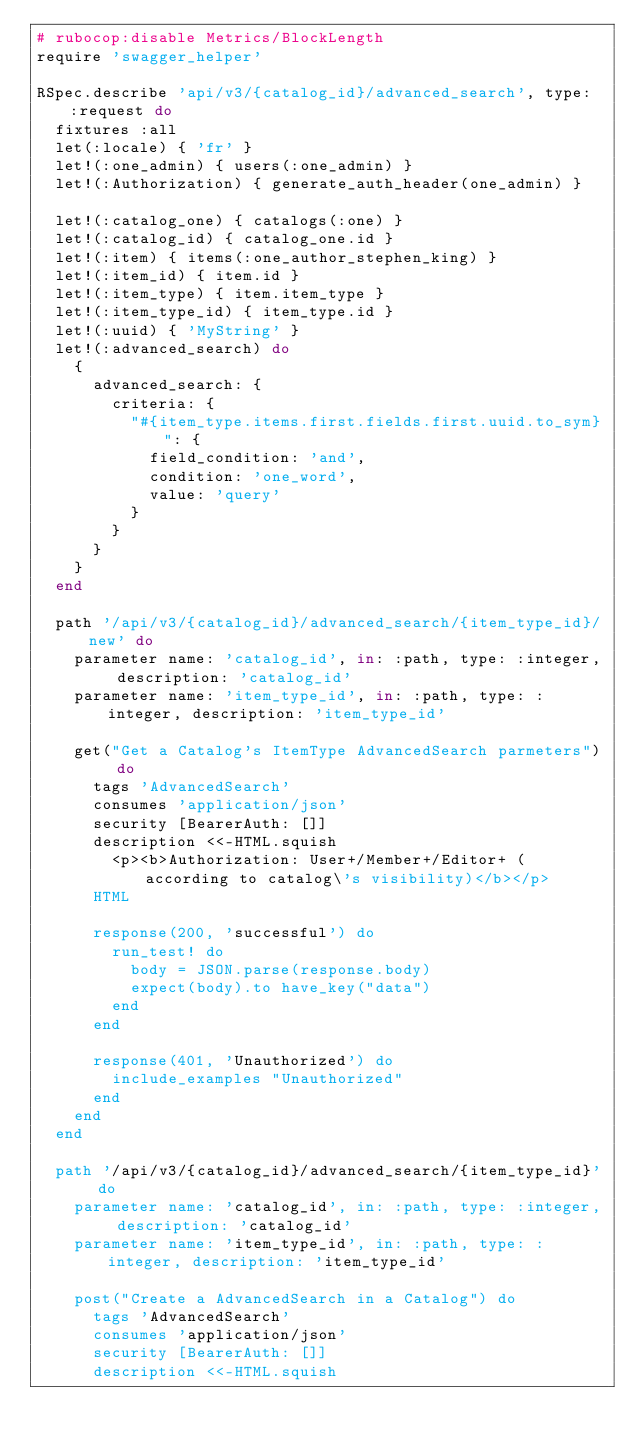Convert code to text. <code><loc_0><loc_0><loc_500><loc_500><_Ruby_># rubocop:disable Metrics/BlockLength
require 'swagger_helper'

RSpec.describe 'api/v3/{catalog_id}/advanced_search', type: :request do
  fixtures :all
  let(:locale) { 'fr' }
  let!(:one_admin) { users(:one_admin) }
  let!(:Authorization) { generate_auth_header(one_admin) }

  let!(:catalog_one) { catalogs(:one) }
  let!(:catalog_id) { catalog_one.id }
  let!(:item) { items(:one_author_stephen_king) }
  let!(:item_id) { item.id }
  let!(:item_type) { item.item_type }
  let!(:item_type_id) { item_type.id }
  let!(:uuid) { 'MyString' }
  let!(:advanced_search) do
    {
      advanced_search: {
        criteria: {
          "#{item_type.items.first.fields.first.uuid.to_sym}": {
            field_condition: 'and',
            condition: 'one_word',
            value: 'query'
          }
        }
      }
    }
  end

  path '/api/v3/{catalog_id}/advanced_search/{item_type_id}/new' do
    parameter name: 'catalog_id', in: :path, type: :integer, description: 'catalog_id'
    parameter name: 'item_type_id', in: :path, type: :integer, description: 'item_type_id'

    get("Get a Catalog's ItemType AdvancedSearch parmeters") do
      tags 'AdvancedSearch'
      consumes 'application/json'
      security [BearerAuth: []]
      description <<-HTML.squish
        <p><b>Authorization: User+/Member+/Editor+ (according to catalog\'s visibility)</b></p>
      HTML

      response(200, 'successful') do
        run_test! do
          body = JSON.parse(response.body)
          expect(body).to have_key("data")
        end
      end

      response(401, 'Unauthorized') do
        include_examples "Unauthorized"
      end
    end
  end

  path '/api/v3/{catalog_id}/advanced_search/{item_type_id}' do
    parameter name: 'catalog_id', in: :path, type: :integer, description: 'catalog_id'
    parameter name: 'item_type_id', in: :path, type: :integer, description: 'item_type_id'

    post("Create a AdvancedSearch in a Catalog") do
      tags 'AdvancedSearch'
      consumes 'application/json'
      security [BearerAuth: []]
      description <<-HTML.squish</code> 